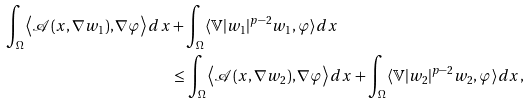Convert formula to latex. <formula><loc_0><loc_0><loc_500><loc_500>\int _ { \Omega } \left \langle \mathcal { A } ( x , \nabla w _ { 1 } ) , \nabla \varphi \right \rangle d x & + { \int _ { \Omega } \langle \mathbb { V } | w _ { 1 } | ^ { p - 2 } w _ { 1 } , \varphi \rangle d x } \\ & \leq \int _ { \Omega } \left \langle \mathcal { A } ( x , \nabla w _ { 2 } ) , \nabla \varphi \right \rangle d x + { \int _ { \Omega } \langle \mathbb { V } | w _ { 2 } | ^ { p - 2 } w _ { 2 } , \varphi \rangle d x } ,</formula> 